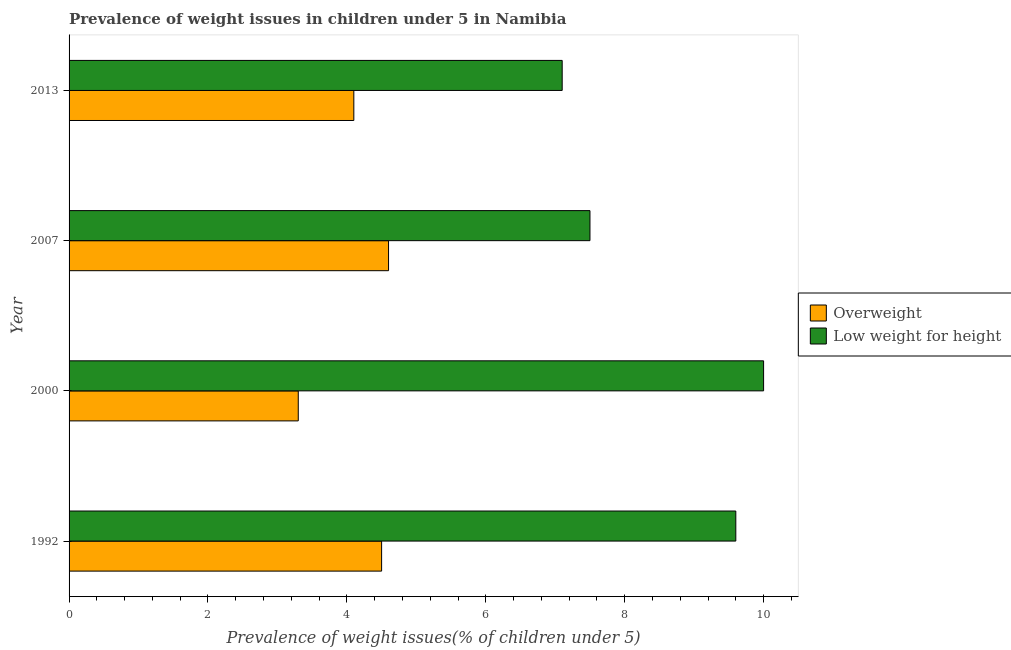How many groups of bars are there?
Give a very brief answer. 4. Are the number of bars per tick equal to the number of legend labels?
Make the answer very short. Yes. In how many cases, is the number of bars for a given year not equal to the number of legend labels?
Your answer should be very brief. 0. What is the percentage of overweight children in 2000?
Provide a short and direct response. 3.3. Across all years, what is the maximum percentage of overweight children?
Ensure brevity in your answer.  4.6. Across all years, what is the minimum percentage of overweight children?
Ensure brevity in your answer.  3.3. What is the total percentage of underweight children in the graph?
Your answer should be very brief. 34.2. What is the difference between the percentage of overweight children in 1992 and that in 2013?
Give a very brief answer. 0.4. What is the difference between the percentage of overweight children in 2000 and the percentage of underweight children in 2013?
Offer a very short reply. -3.8. What is the average percentage of underweight children per year?
Ensure brevity in your answer.  8.55. In the year 1992, what is the difference between the percentage of underweight children and percentage of overweight children?
Provide a short and direct response. 5.1. In how many years, is the percentage of overweight children greater than 4.4 %?
Give a very brief answer. 2. What is the ratio of the percentage of overweight children in 2007 to that in 2013?
Provide a short and direct response. 1.12. Is the percentage of overweight children in 2000 less than that in 2013?
Give a very brief answer. Yes. What is the difference between the highest and the second highest percentage of underweight children?
Offer a very short reply. 0.4. What does the 2nd bar from the top in 1992 represents?
Give a very brief answer. Overweight. What does the 2nd bar from the bottom in 2007 represents?
Your answer should be compact. Low weight for height. How many years are there in the graph?
Keep it short and to the point. 4. Are the values on the major ticks of X-axis written in scientific E-notation?
Provide a short and direct response. No. Does the graph contain grids?
Your answer should be compact. No. What is the title of the graph?
Offer a very short reply. Prevalence of weight issues in children under 5 in Namibia. Does "Taxes on exports" appear as one of the legend labels in the graph?
Offer a very short reply. No. What is the label or title of the X-axis?
Provide a succinct answer. Prevalence of weight issues(% of children under 5). What is the label or title of the Y-axis?
Keep it short and to the point. Year. What is the Prevalence of weight issues(% of children under 5) of Overweight in 1992?
Your response must be concise. 4.5. What is the Prevalence of weight issues(% of children under 5) of Low weight for height in 1992?
Make the answer very short. 9.6. What is the Prevalence of weight issues(% of children under 5) in Overweight in 2000?
Your answer should be compact. 3.3. What is the Prevalence of weight issues(% of children under 5) in Low weight for height in 2000?
Keep it short and to the point. 10. What is the Prevalence of weight issues(% of children under 5) of Overweight in 2007?
Ensure brevity in your answer.  4.6. What is the Prevalence of weight issues(% of children under 5) of Overweight in 2013?
Offer a very short reply. 4.1. What is the Prevalence of weight issues(% of children under 5) in Low weight for height in 2013?
Make the answer very short. 7.1. Across all years, what is the maximum Prevalence of weight issues(% of children under 5) of Overweight?
Your answer should be very brief. 4.6. Across all years, what is the maximum Prevalence of weight issues(% of children under 5) of Low weight for height?
Keep it short and to the point. 10. Across all years, what is the minimum Prevalence of weight issues(% of children under 5) of Overweight?
Give a very brief answer. 3.3. Across all years, what is the minimum Prevalence of weight issues(% of children under 5) of Low weight for height?
Give a very brief answer. 7.1. What is the total Prevalence of weight issues(% of children under 5) of Overweight in the graph?
Make the answer very short. 16.5. What is the total Prevalence of weight issues(% of children under 5) of Low weight for height in the graph?
Your answer should be very brief. 34.2. What is the difference between the Prevalence of weight issues(% of children under 5) in Overweight in 1992 and that in 2000?
Provide a succinct answer. 1.2. What is the difference between the Prevalence of weight issues(% of children under 5) of Overweight in 1992 and that in 2013?
Provide a succinct answer. 0.4. What is the difference between the Prevalence of weight issues(% of children under 5) of Low weight for height in 1992 and that in 2013?
Keep it short and to the point. 2.5. What is the difference between the Prevalence of weight issues(% of children under 5) in Overweight in 2000 and that in 2013?
Your answer should be compact. -0.8. What is the difference between the Prevalence of weight issues(% of children under 5) of Low weight for height in 2000 and that in 2013?
Your answer should be compact. 2.9. What is the difference between the Prevalence of weight issues(% of children under 5) of Overweight in 2007 and that in 2013?
Offer a terse response. 0.5. What is the difference between the Prevalence of weight issues(% of children under 5) of Overweight in 1992 and the Prevalence of weight issues(% of children under 5) of Low weight for height in 2000?
Make the answer very short. -5.5. What is the difference between the Prevalence of weight issues(% of children under 5) of Overweight in 1992 and the Prevalence of weight issues(% of children under 5) of Low weight for height in 2007?
Make the answer very short. -3. What is the difference between the Prevalence of weight issues(% of children under 5) in Overweight in 1992 and the Prevalence of weight issues(% of children under 5) in Low weight for height in 2013?
Give a very brief answer. -2.6. What is the difference between the Prevalence of weight issues(% of children under 5) in Overweight in 2007 and the Prevalence of weight issues(% of children under 5) in Low weight for height in 2013?
Your response must be concise. -2.5. What is the average Prevalence of weight issues(% of children under 5) of Overweight per year?
Make the answer very short. 4.12. What is the average Prevalence of weight issues(% of children under 5) in Low weight for height per year?
Your answer should be compact. 8.55. In the year 2000, what is the difference between the Prevalence of weight issues(% of children under 5) of Overweight and Prevalence of weight issues(% of children under 5) of Low weight for height?
Provide a succinct answer. -6.7. In the year 2007, what is the difference between the Prevalence of weight issues(% of children under 5) in Overweight and Prevalence of weight issues(% of children under 5) in Low weight for height?
Offer a very short reply. -2.9. What is the ratio of the Prevalence of weight issues(% of children under 5) in Overweight in 1992 to that in 2000?
Your response must be concise. 1.36. What is the ratio of the Prevalence of weight issues(% of children under 5) of Overweight in 1992 to that in 2007?
Your response must be concise. 0.98. What is the ratio of the Prevalence of weight issues(% of children under 5) in Low weight for height in 1992 to that in 2007?
Your answer should be compact. 1.28. What is the ratio of the Prevalence of weight issues(% of children under 5) of Overweight in 1992 to that in 2013?
Ensure brevity in your answer.  1.1. What is the ratio of the Prevalence of weight issues(% of children under 5) of Low weight for height in 1992 to that in 2013?
Your answer should be compact. 1.35. What is the ratio of the Prevalence of weight issues(% of children under 5) of Overweight in 2000 to that in 2007?
Your response must be concise. 0.72. What is the ratio of the Prevalence of weight issues(% of children under 5) in Low weight for height in 2000 to that in 2007?
Make the answer very short. 1.33. What is the ratio of the Prevalence of weight issues(% of children under 5) of Overweight in 2000 to that in 2013?
Your answer should be compact. 0.8. What is the ratio of the Prevalence of weight issues(% of children under 5) in Low weight for height in 2000 to that in 2013?
Give a very brief answer. 1.41. What is the ratio of the Prevalence of weight issues(% of children under 5) of Overweight in 2007 to that in 2013?
Your answer should be compact. 1.12. What is the ratio of the Prevalence of weight issues(% of children under 5) in Low weight for height in 2007 to that in 2013?
Offer a very short reply. 1.06. What is the difference between the highest and the lowest Prevalence of weight issues(% of children under 5) in Low weight for height?
Make the answer very short. 2.9. 